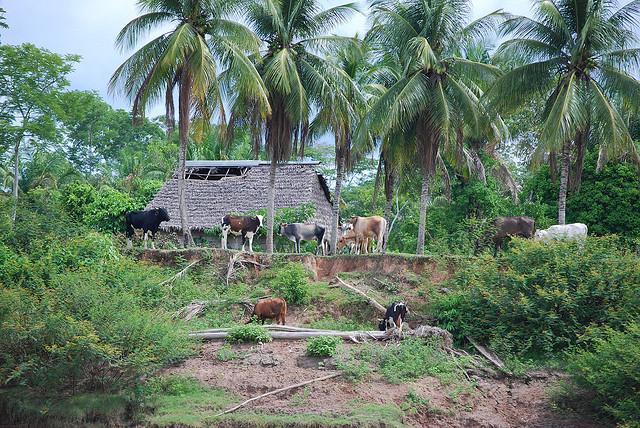Does the image display evidence of too much grazing?
Concise answer only. Yes. Is that bamboo on the top of the shelter?
Short answer required. No. How many animals are there?
Quick response, please. 9. What kind of area is this?
Be succinct. Farm. What color is the grass?
Short answer required. Green. What kind of fence is that?
Answer briefly. Dirt. Which animal is the tallest?
Answer briefly. Cow. What majority of animals is pictured?
Quick response, please. Cows. 